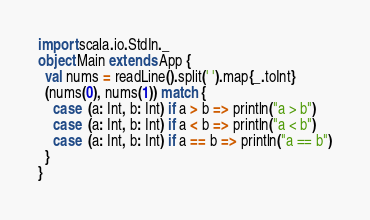Convert code to text. <code><loc_0><loc_0><loc_500><loc_500><_Scala_>import scala.io.StdIn._
object Main extends App {
  val nums = readLine().split(' ').map{_.toInt}
  (nums(0), nums(1)) match {
    case  (a: Int, b: Int) if a > b => println("a > b")
    case  (a: Int, b: Int) if a < b => println("a < b")
    case  (a: Int, b: Int) if a == b => println("a == b")
  }
}</code> 